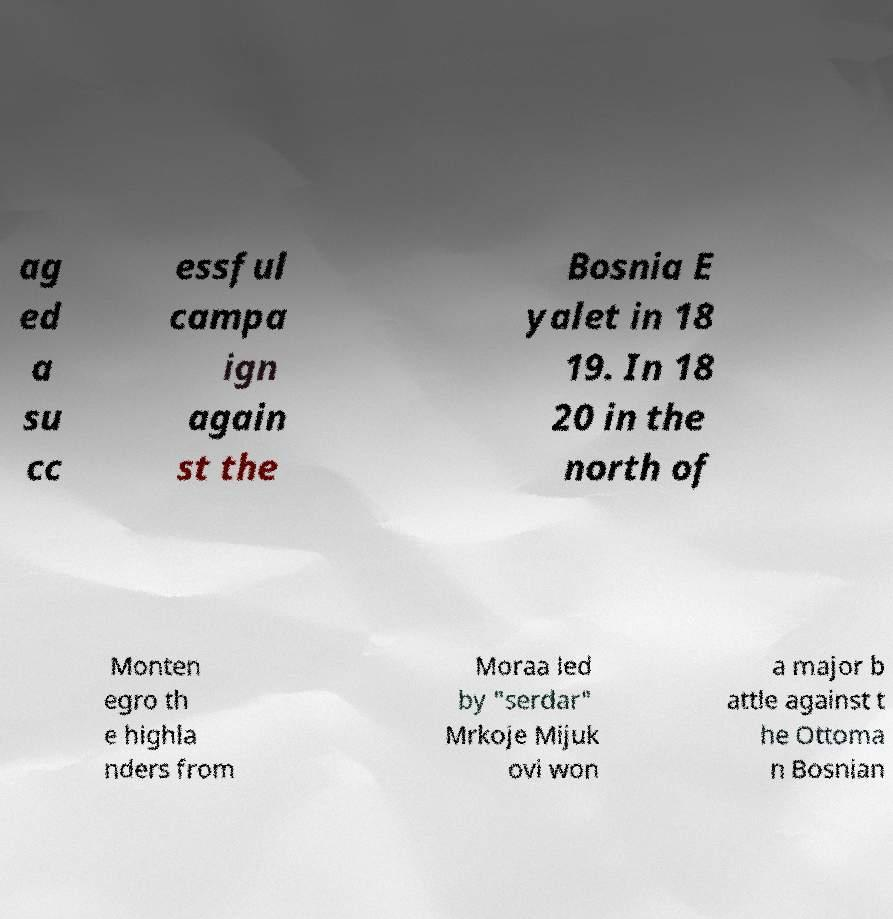There's text embedded in this image that I need extracted. Can you transcribe it verbatim? ag ed a su cc essful campa ign again st the Bosnia E yalet in 18 19. In 18 20 in the north of Monten egro th e highla nders from Moraa led by "serdar" Mrkoje Mijuk ovi won a major b attle against t he Ottoma n Bosnian 